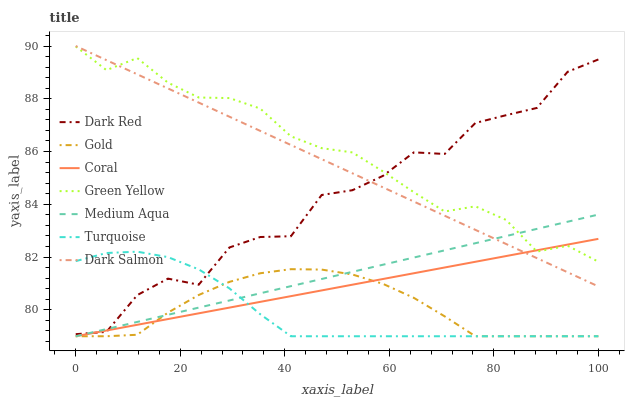Does Turquoise have the minimum area under the curve?
Answer yes or no. Yes. Does Green Yellow have the maximum area under the curve?
Answer yes or no. Yes. Does Gold have the minimum area under the curve?
Answer yes or no. No. Does Gold have the maximum area under the curve?
Answer yes or no. No. Is Dark Salmon the smoothest?
Answer yes or no. Yes. Is Dark Red the roughest?
Answer yes or no. Yes. Is Gold the smoothest?
Answer yes or no. No. Is Gold the roughest?
Answer yes or no. No. Does Turquoise have the lowest value?
Answer yes or no. Yes. Does Dark Red have the lowest value?
Answer yes or no. No. Does Dark Salmon have the highest value?
Answer yes or no. Yes. Does Dark Red have the highest value?
Answer yes or no. No. Is Turquoise less than Green Yellow?
Answer yes or no. Yes. Is Green Yellow greater than Turquoise?
Answer yes or no. Yes. Does Green Yellow intersect Dark Salmon?
Answer yes or no. Yes. Is Green Yellow less than Dark Salmon?
Answer yes or no. No. Is Green Yellow greater than Dark Salmon?
Answer yes or no. No. Does Turquoise intersect Green Yellow?
Answer yes or no. No. 